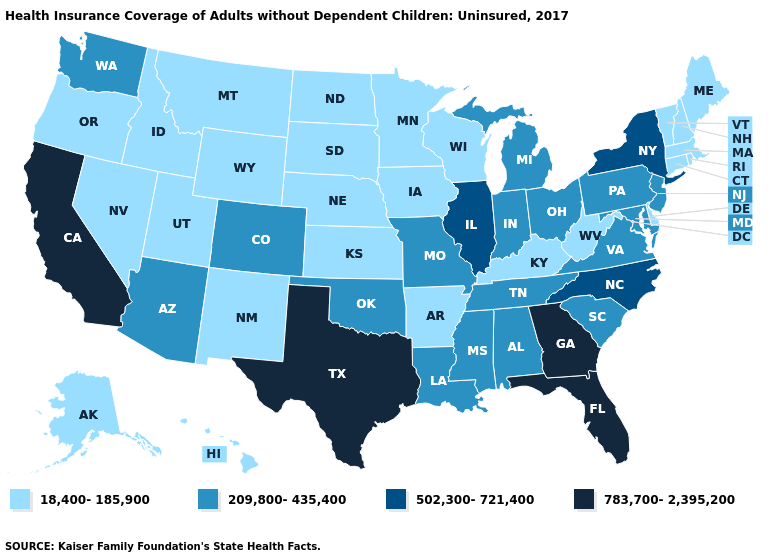What is the value of Mississippi?
Be succinct. 209,800-435,400. Which states have the lowest value in the USA?
Give a very brief answer. Alaska, Arkansas, Connecticut, Delaware, Hawaii, Idaho, Iowa, Kansas, Kentucky, Maine, Massachusetts, Minnesota, Montana, Nebraska, Nevada, New Hampshire, New Mexico, North Dakota, Oregon, Rhode Island, South Dakota, Utah, Vermont, West Virginia, Wisconsin, Wyoming. What is the value of Ohio?
Give a very brief answer. 209,800-435,400. Does Minnesota have the lowest value in the USA?
Keep it brief. Yes. Among the states that border Kansas , does Oklahoma have the lowest value?
Concise answer only. No. Does the first symbol in the legend represent the smallest category?
Quick response, please. Yes. Does Alaska have the same value as Mississippi?
Quick response, please. No. Does the first symbol in the legend represent the smallest category?
Answer briefly. Yes. Does Colorado have the lowest value in the West?
Answer briefly. No. Name the states that have a value in the range 209,800-435,400?
Answer briefly. Alabama, Arizona, Colorado, Indiana, Louisiana, Maryland, Michigan, Mississippi, Missouri, New Jersey, Ohio, Oklahoma, Pennsylvania, South Carolina, Tennessee, Virginia, Washington. Does the first symbol in the legend represent the smallest category?
Write a very short answer. Yes. Does New York have the lowest value in the Northeast?
Answer briefly. No. What is the value of Arkansas?
Be succinct. 18,400-185,900. Name the states that have a value in the range 783,700-2,395,200?
Short answer required. California, Florida, Georgia, Texas. Name the states that have a value in the range 18,400-185,900?
Quick response, please. Alaska, Arkansas, Connecticut, Delaware, Hawaii, Idaho, Iowa, Kansas, Kentucky, Maine, Massachusetts, Minnesota, Montana, Nebraska, Nevada, New Hampshire, New Mexico, North Dakota, Oregon, Rhode Island, South Dakota, Utah, Vermont, West Virginia, Wisconsin, Wyoming. 